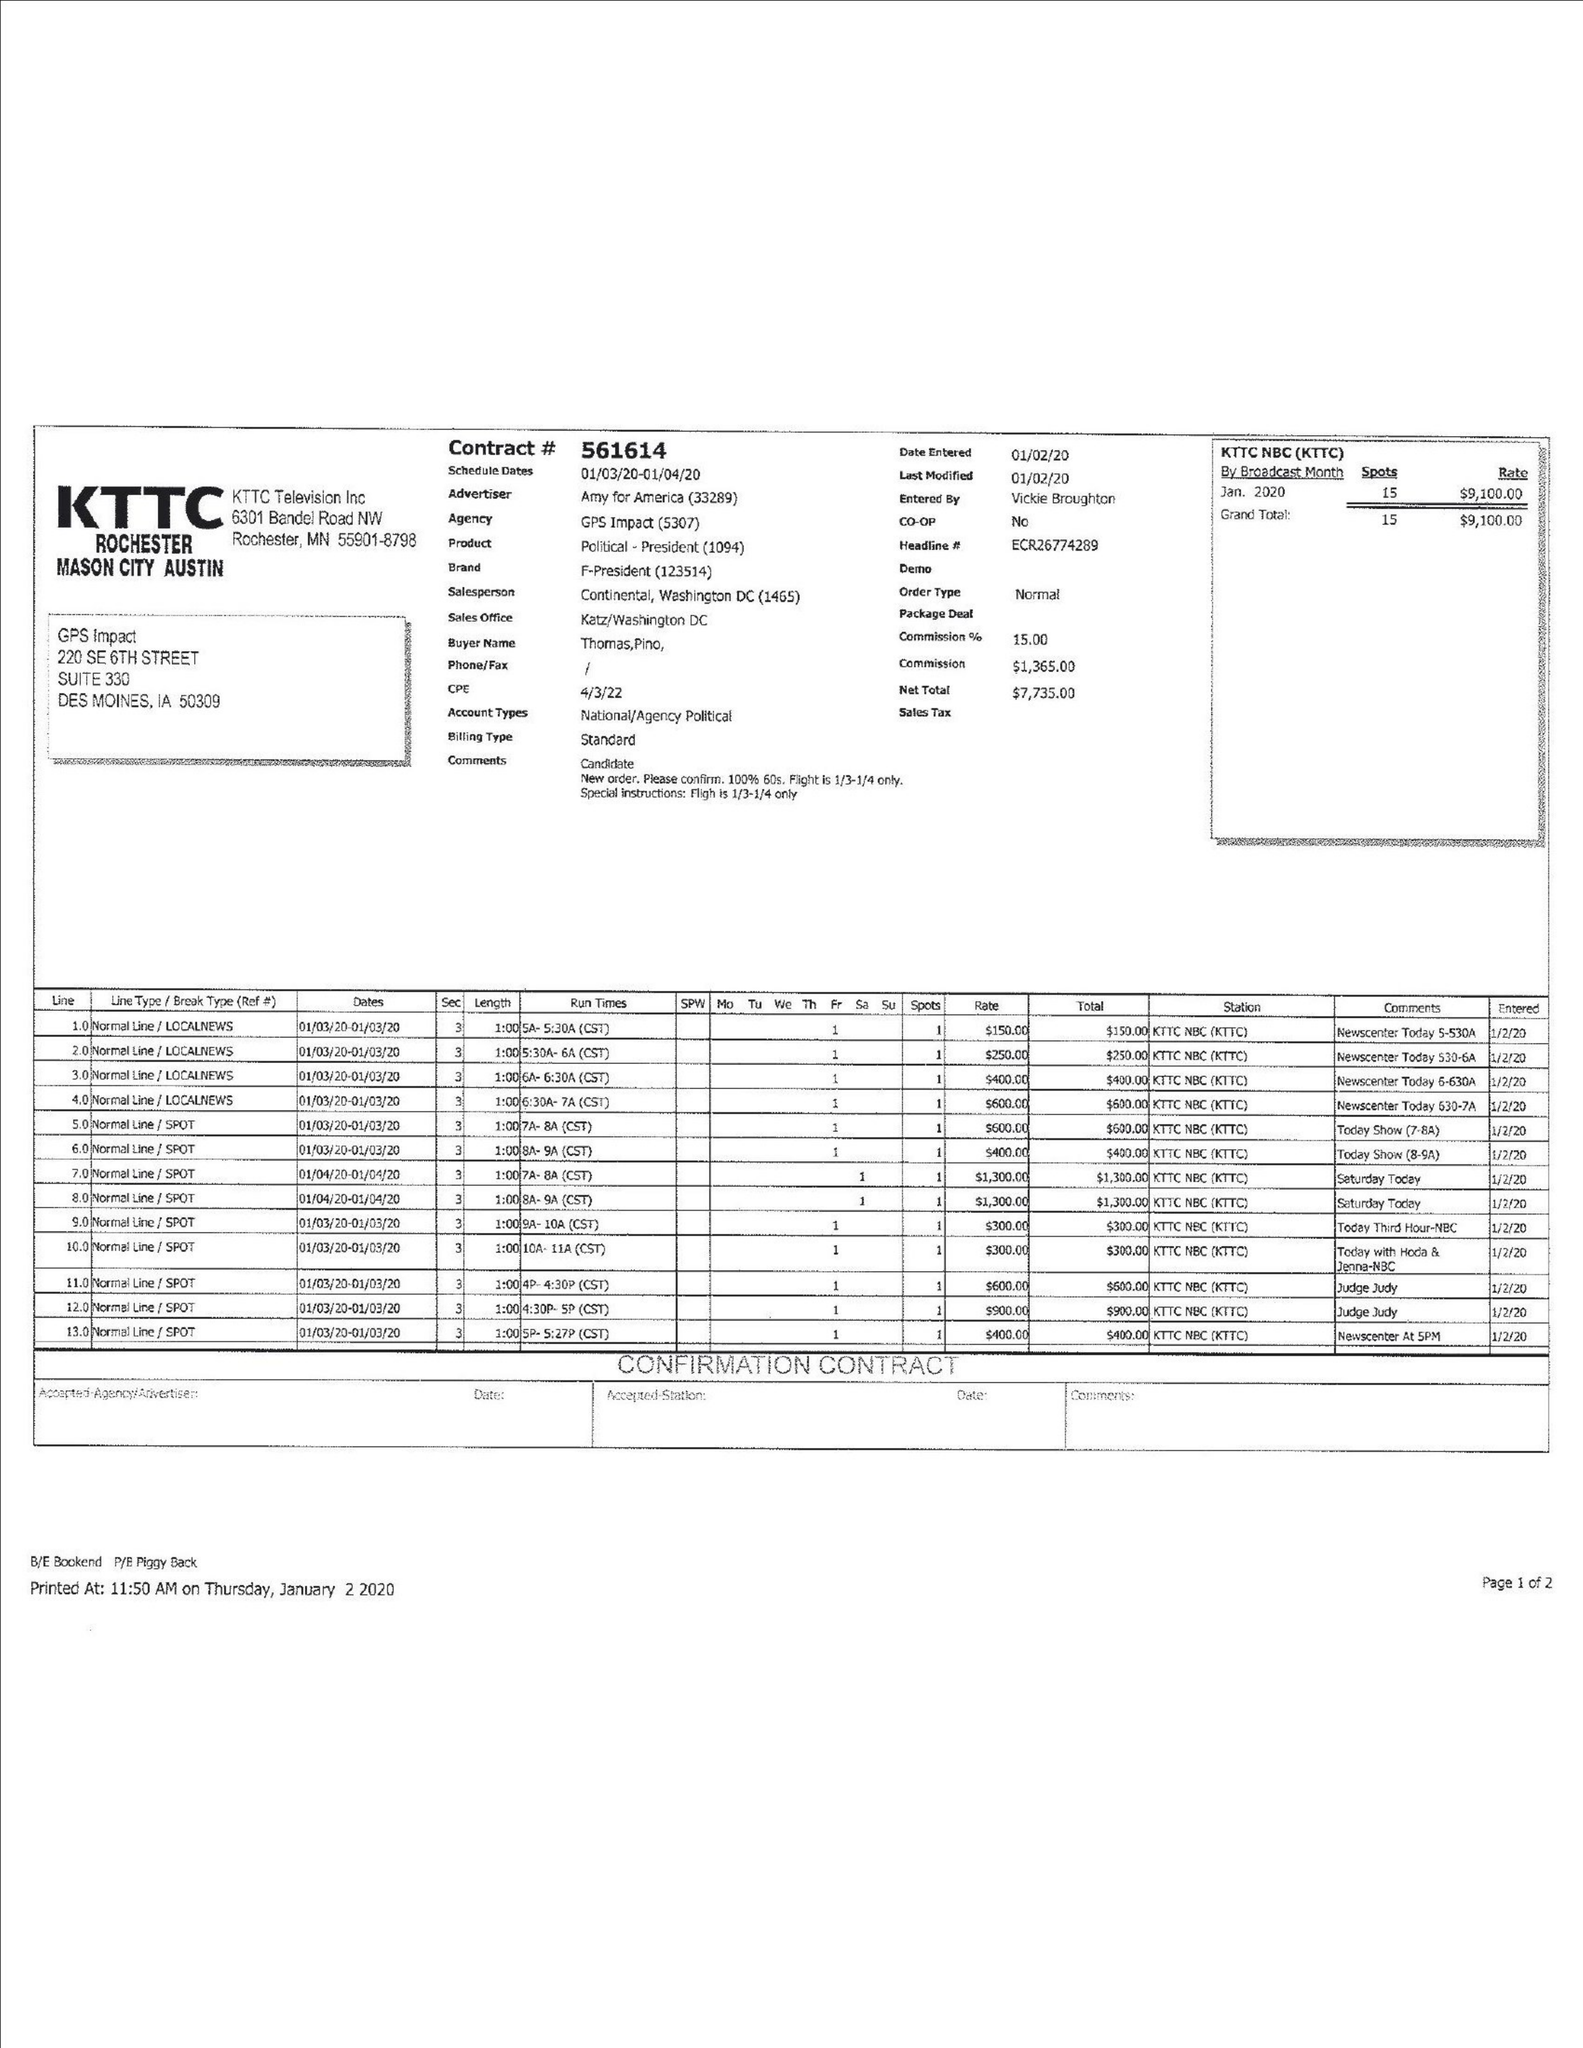What is the value for the flight_to?
Answer the question using a single word or phrase. 01/04/20 